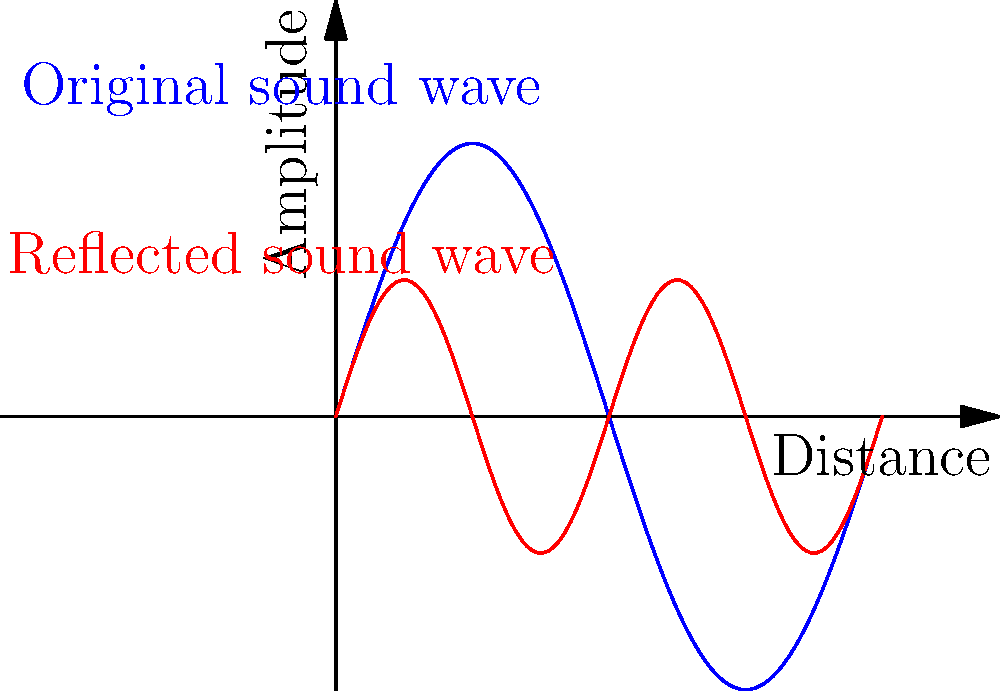In the acoustic design of a courtroom, sound waves are crucial for clear communication. The diagram shows an original sound wave (blue) and its reflection (red) in a courtroom. How does the reflected wave's frequency compare to the original, and what acoustic principle does this demonstrate? To analyze the acoustic design principle demonstrated in this courtroom scenario, let's follow these steps:

1. Observe the original sound wave (blue):
   - It completes one full cycle in the given distance.
   - This represents the fundamental frequency of the sound.

2. Examine the reflected sound wave (red):
   - It completes two full cycles in the same distance as the original wave.
   - This indicates that its frequency is twice that of the original wave.

3. Compare the amplitudes:
   - The reflected wave has a smaller amplitude than the original.
   - This suggests some energy loss during reflection.

4. Identify the acoustic principle:
   - When sound waves reflect off hard surfaces, they can change in frequency and amplitude.
   - This phenomenon is known as flutter echo or standing waves.

5. Implications for courtroom design:
   - Flutter echoes can cause sound distortion and reduce speech intelligibility.
   - Acoustic treatments like diffusers or absorbers are often used to mitigate this effect.

6. Relevance to marriage equality cases:
   - Clear communication is crucial in legal proceedings, especially for sensitive topics.
   - Proper acoustic design ensures all testimonies and arguments are heard clearly by the court.

The reflected wave demonstrates a frequency doubling, illustrating the principle of flutter echo in room acoustics.
Answer: The reflected wave has twice the frequency of the original, demonstrating flutter echo. 